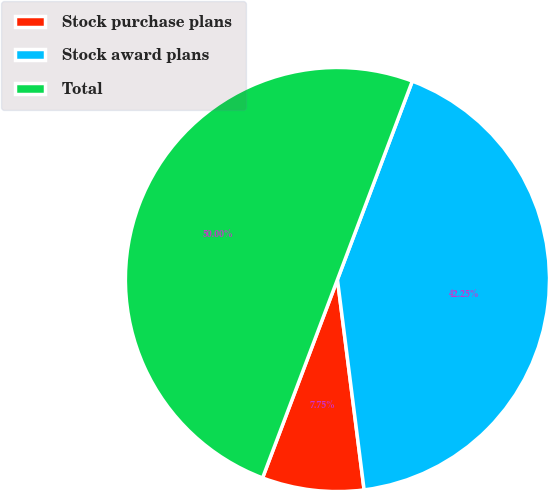Convert chart. <chart><loc_0><loc_0><loc_500><loc_500><pie_chart><fcel>Stock purchase plans<fcel>Stock award plans<fcel>Total<nl><fcel>7.75%<fcel>42.25%<fcel>50.0%<nl></chart> 